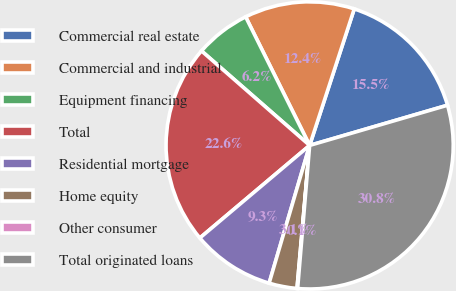<chart> <loc_0><loc_0><loc_500><loc_500><pie_chart><fcel>Commercial real estate<fcel>Commercial and industrial<fcel>Equipment financing<fcel>Total<fcel>Residential mortgage<fcel>Home equity<fcel>Other consumer<fcel>Total originated loans<nl><fcel>15.46%<fcel>12.38%<fcel>6.22%<fcel>22.58%<fcel>9.3%<fcel>3.15%<fcel>0.07%<fcel>30.85%<nl></chart> 